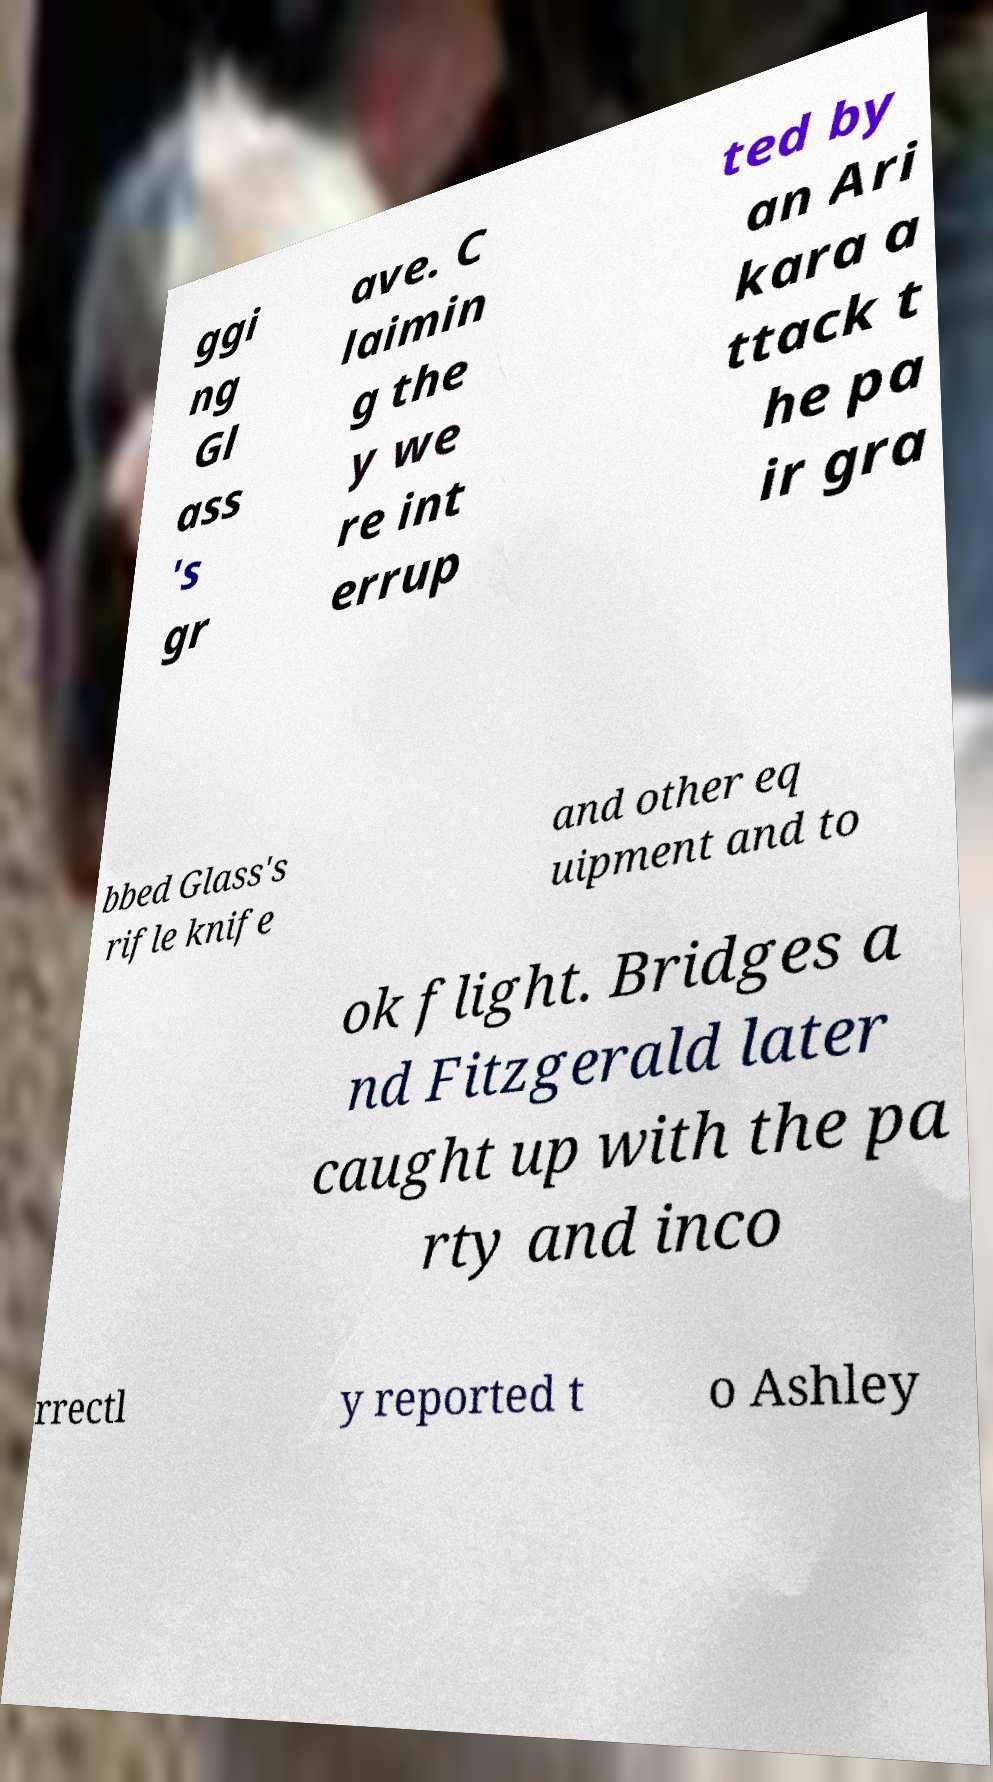Can you read and provide the text displayed in the image?This photo seems to have some interesting text. Can you extract and type it out for me? ggi ng Gl ass 's gr ave. C laimin g the y we re int errup ted by an Ari kara a ttack t he pa ir gra bbed Glass's rifle knife and other eq uipment and to ok flight. Bridges a nd Fitzgerald later caught up with the pa rty and inco rrectl y reported t o Ashley 